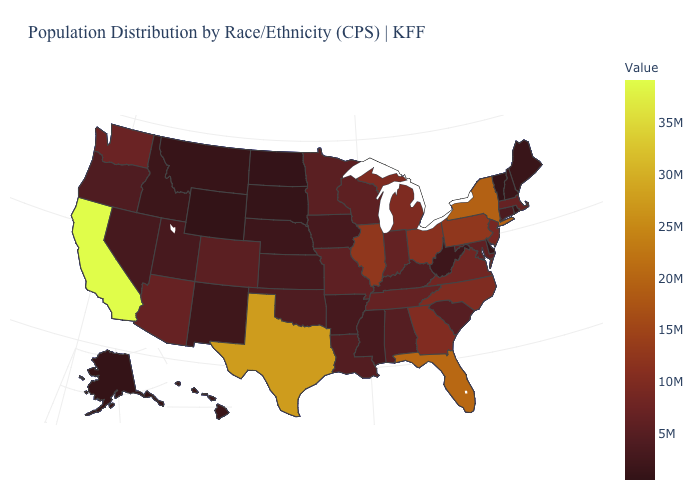Does Texas have the highest value in the South?
Short answer required. Yes. Among the states that border Virginia , does Kentucky have the lowest value?
Be succinct. No. Is the legend a continuous bar?
Quick response, please. Yes. Among the states that border Iowa , which have the highest value?
Give a very brief answer. Illinois. Does North Dakota have the highest value in the USA?
Concise answer only. No. 